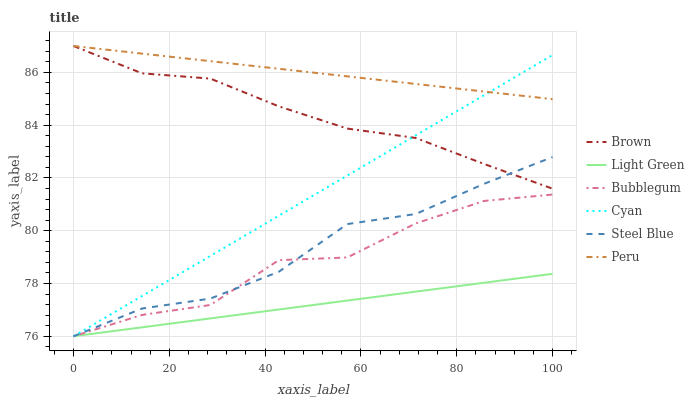Does Light Green have the minimum area under the curve?
Answer yes or no. Yes. Does Peru have the maximum area under the curve?
Answer yes or no. Yes. Does Steel Blue have the minimum area under the curve?
Answer yes or no. No. Does Steel Blue have the maximum area under the curve?
Answer yes or no. No. Is Peru the smoothest?
Answer yes or no. Yes. Is Bubblegum the roughest?
Answer yes or no. Yes. Is Light Green the smoothest?
Answer yes or no. No. Is Light Green the roughest?
Answer yes or no. No. Does Light Green have the lowest value?
Answer yes or no. Yes. Does Peru have the lowest value?
Answer yes or no. No. Does Peru have the highest value?
Answer yes or no. Yes. Does Steel Blue have the highest value?
Answer yes or no. No. Is Light Green less than Brown?
Answer yes or no. Yes. Is Peru greater than Light Green?
Answer yes or no. Yes. Does Peru intersect Cyan?
Answer yes or no. Yes. Is Peru less than Cyan?
Answer yes or no. No. Is Peru greater than Cyan?
Answer yes or no. No. Does Light Green intersect Brown?
Answer yes or no. No. 